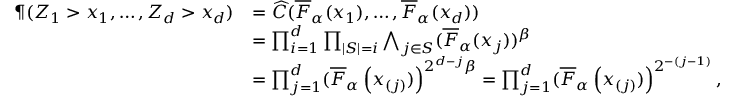<formula> <loc_0><loc_0><loc_500><loc_500>\begin{array} { r l } { \P ( Z _ { 1 } > x _ { 1 } , \dots , Z _ { d } > x _ { d } ) } & { = \widehat { C } ( \overline { F } _ { \alpha } ( x _ { 1 } ) , \dots , \overline { F } _ { \alpha } ( x _ { d } ) ) } \\ & { = \prod _ { i = 1 } ^ { d } \prod _ { | S | = i } \bigwedge _ { j \in S } ( \overline { F } _ { \alpha } ( x _ { j } ) ) ^ { \beta } } \\ & { = \prod _ { j = 1 } ^ { d } ( \overline { F } _ { \alpha } \left ( x _ { ( j ) } ) \right ) ^ { 2 ^ { d - j } \beta } = \prod _ { j = 1 } ^ { d } ( \overline { F } _ { \alpha } \left ( x _ { ( j ) } ) \right ) ^ { 2 ^ { - ( j - 1 ) } } , } \end{array}</formula> 